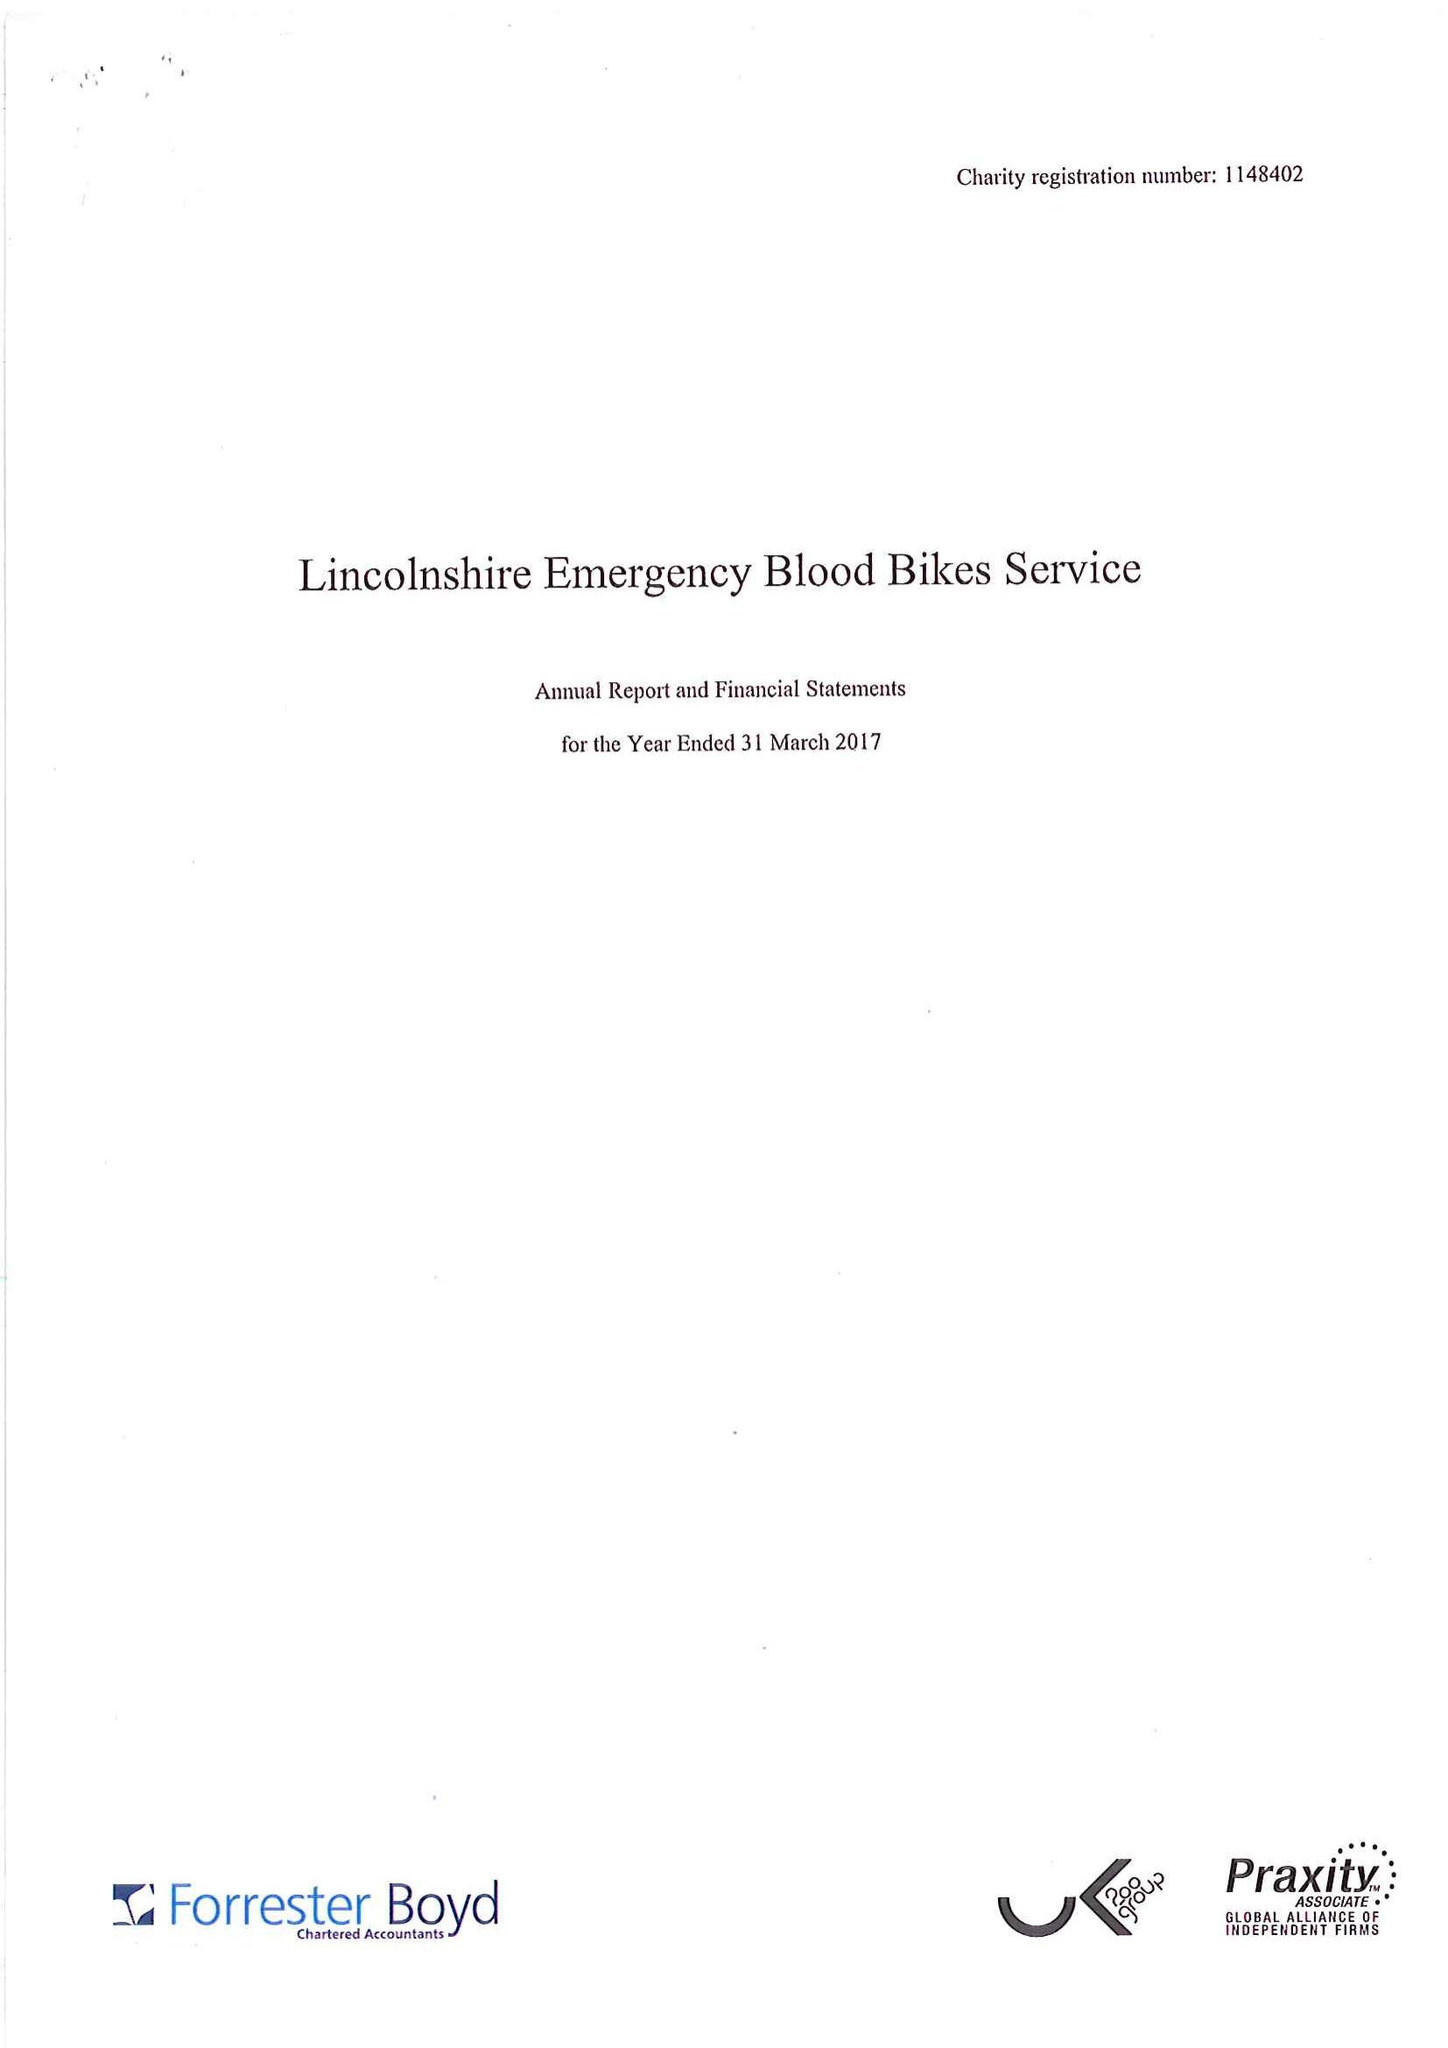What is the value for the charity_number?
Answer the question using a single word or phrase. 1148402 